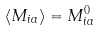<formula> <loc_0><loc_0><loc_500><loc_500>\langle M _ { i a } \rangle = M _ { i a } ^ { 0 }</formula> 